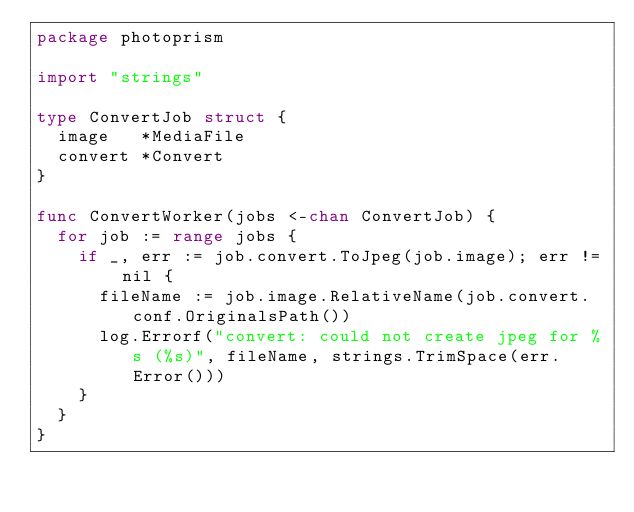Convert code to text. <code><loc_0><loc_0><loc_500><loc_500><_Go_>package photoprism

import "strings"

type ConvertJob struct {
	image   *MediaFile
	convert *Convert
}

func ConvertWorker(jobs <-chan ConvertJob) {
	for job := range jobs {
		if _, err := job.convert.ToJpeg(job.image); err != nil {
			fileName := job.image.RelativeName(job.convert.conf.OriginalsPath())
			log.Errorf("convert: could not create jpeg for %s (%s)", fileName, strings.TrimSpace(err.Error()))
		}
	}
}
</code> 